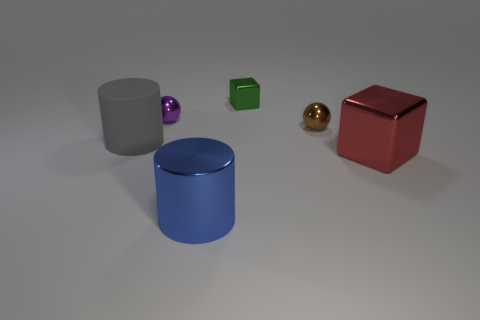What number of other things are there of the same size as the brown metallic object?
Your answer should be compact. 2. There is a sphere behind the small brown shiny object; what size is it?
Offer a terse response. Small. Do the large object that is right of the brown object and the small brown ball have the same material?
Your answer should be very brief. Yes. How many objects are both to the left of the small brown metallic object and in front of the purple thing?
Provide a short and direct response. 2. What is the size of the shiny cube in front of the metallic cube behind the red object?
Your response must be concise. Large. Are there any other things that have the same material as the gray thing?
Offer a very short reply. No. Are there more big red things than brown rubber cylinders?
Offer a terse response. Yes. Are there any shiny balls right of the green object that is behind the blue cylinder?
Offer a very short reply. Yes. Is the number of matte objects that are on the left side of the big gray matte object less than the number of tiny metallic things that are to the right of the purple metallic object?
Provide a succinct answer. Yes. Is the material of the large cylinder behind the large blue metal thing the same as the big cylinder in front of the gray cylinder?
Keep it short and to the point. No. 